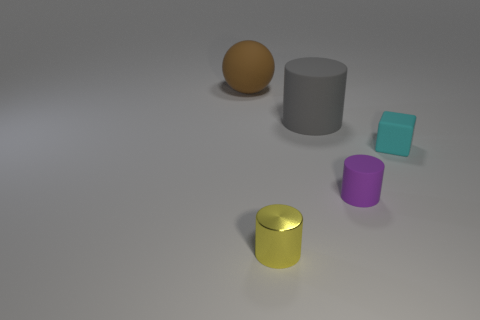Add 1 tiny cyan matte blocks. How many objects exist? 6 Subtract all cylinders. How many objects are left? 2 Subtract all small purple rubber objects. Subtract all cyan matte objects. How many objects are left? 3 Add 3 small purple rubber cylinders. How many small purple rubber cylinders are left? 4 Add 1 yellow shiny things. How many yellow shiny things exist? 2 Subtract 1 gray cylinders. How many objects are left? 4 